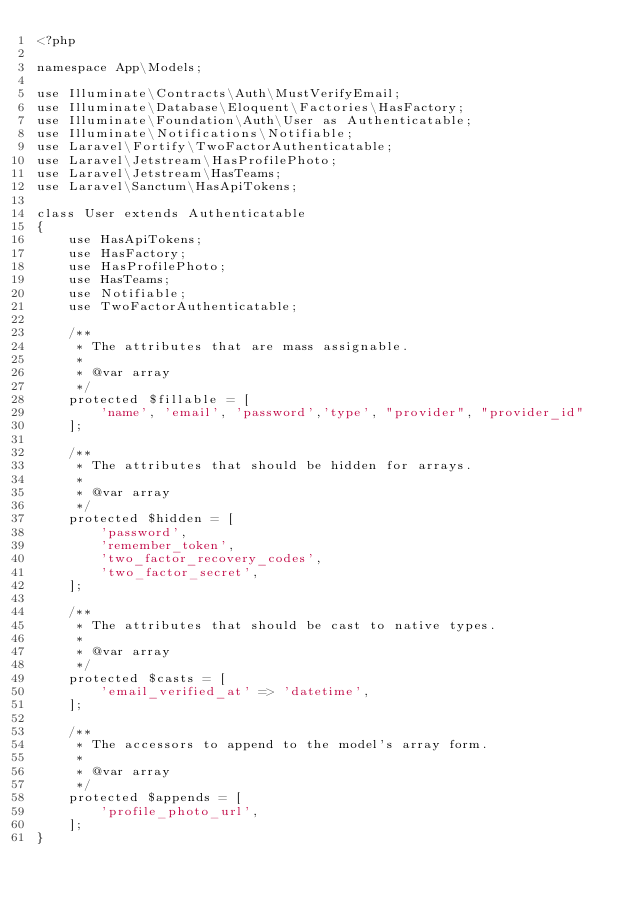<code> <loc_0><loc_0><loc_500><loc_500><_PHP_><?php

namespace App\Models;

use Illuminate\Contracts\Auth\MustVerifyEmail;
use Illuminate\Database\Eloquent\Factories\HasFactory;
use Illuminate\Foundation\Auth\User as Authenticatable;
use Illuminate\Notifications\Notifiable;
use Laravel\Fortify\TwoFactorAuthenticatable;
use Laravel\Jetstream\HasProfilePhoto;
use Laravel\Jetstream\HasTeams;
use Laravel\Sanctum\HasApiTokens;

class User extends Authenticatable
{
    use HasApiTokens;
    use HasFactory;
    use HasProfilePhoto;
    use HasTeams;
    use Notifiable;
    use TwoFactorAuthenticatable;

    /**
     * The attributes that are mass assignable.
     *
     * @var array
     */
    protected $fillable = [
        'name', 'email', 'password','type', "provider", "provider_id"
    ];

    /**
     * The attributes that should be hidden for arrays.
     *
     * @var array
     */
    protected $hidden = [
        'password',
        'remember_token',
        'two_factor_recovery_codes',
        'two_factor_secret',
    ];

    /**
     * The attributes that should be cast to native types.
     *
     * @var array
     */
    protected $casts = [
        'email_verified_at' => 'datetime',
    ];

    /**
     * The accessors to append to the model's array form.
     *
     * @var array
     */
    protected $appends = [
        'profile_photo_url',
    ];
}
</code> 